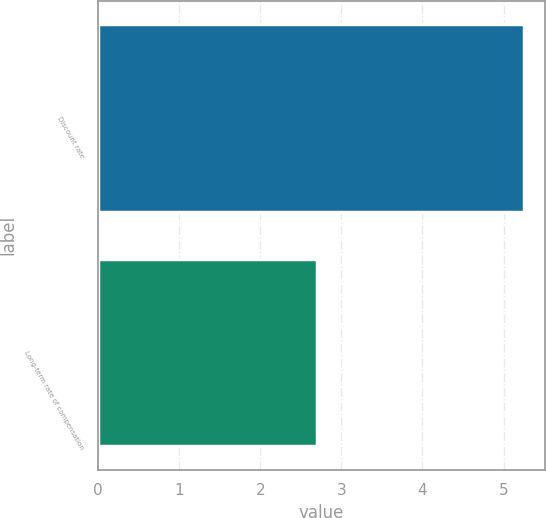Convert chart. <chart><loc_0><loc_0><loc_500><loc_500><bar_chart><fcel>Discount rate<fcel>Long-term rate of compensation<nl><fcel>5.25<fcel>2.7<nl></chart> 